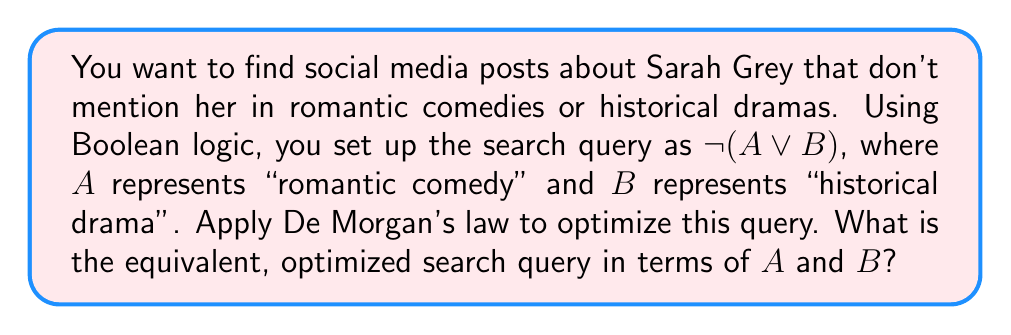Solve this math problem. Let's approach this step-by-step using De Morgan's law:

1. We start with the original query: NOT(A OR B)

2. De Morgan's law states that the negation of a disjunction is the conjunction of the negations. In Boolean algebra, this is expressed as:

   $$ \overline{A \lor B} = \overline{A} \land \overline{B} $$

3. Applying this to our query:
   NOT(A OR B) becomes (NOT A) AND (NOT B)

4. In terms of our search:
   - NOT A means "not romantic comedy"
   - NOT B means "not historical drama"

5. The optimized query is therefore:
   (NOT A) AND (NOT B)

This optimized form allows search engines to directly filter out posts mentioning romantic comedies and historical dramas, potentially improving search efficiency.
Answer: $(NOT A) AND (NOT B)$ 